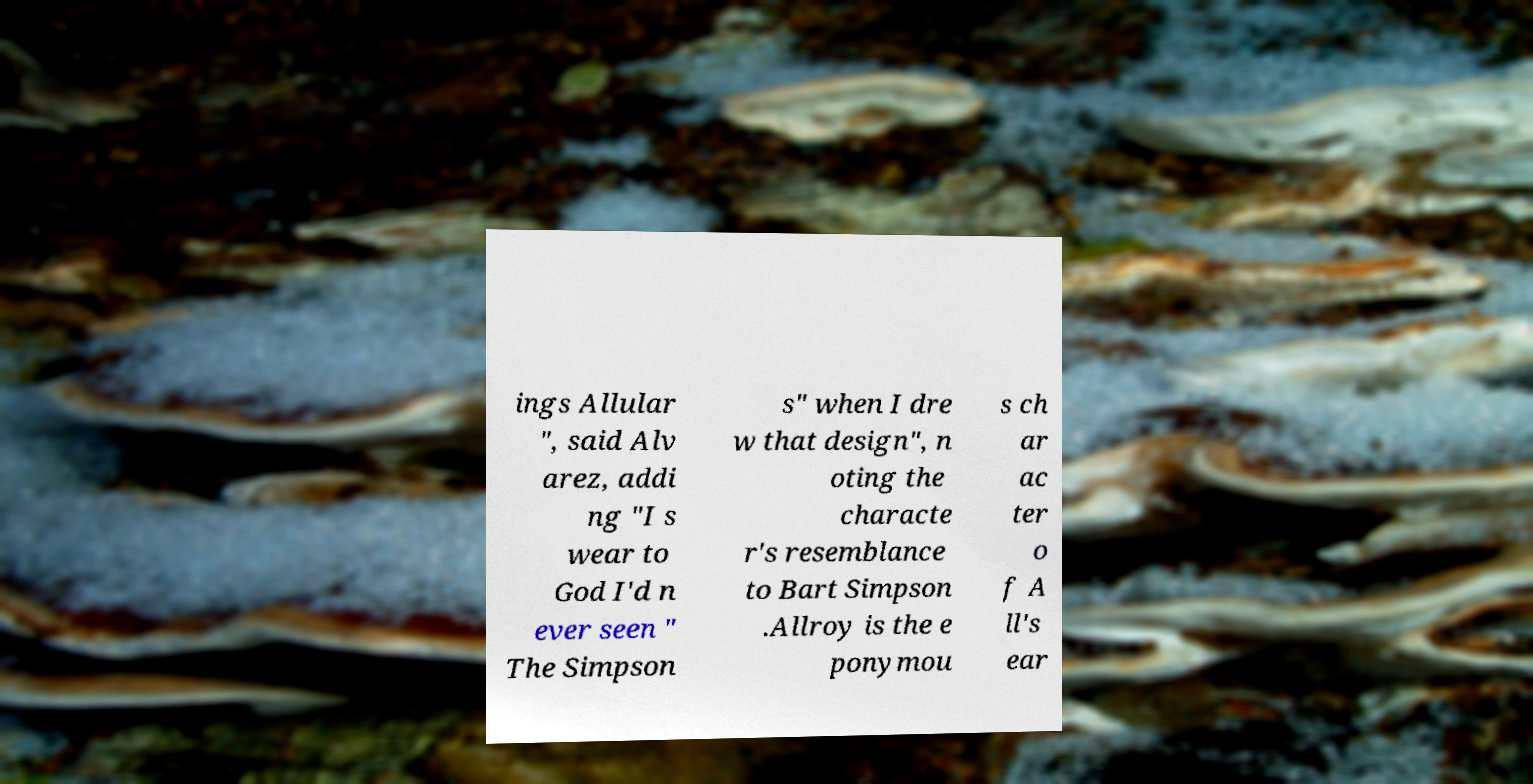For documentation purposes, I need the text within this image transcribed. Could you provide that? ings Allular ", said Alv arez, addi ng "I s wear to God I'd n ever seen " The Simpson s" when I dre w that design", n oting the characte r's resemblance to Bart Simpson .Allroy is the e ponymou s ch ar ac ter o f A ll's ear 